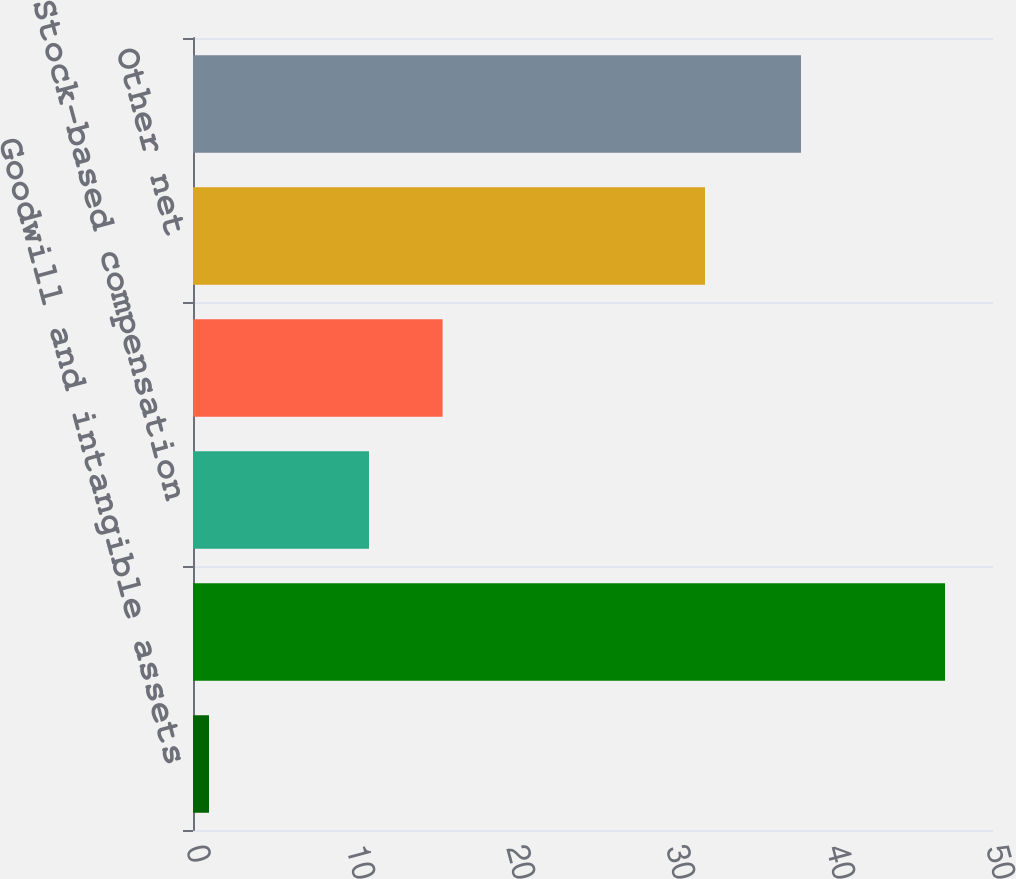<chart> <loc_0><loc_0><loc_500><loc_500><bar_chart><fcel>Goodwill and intangible assets<fcel>Pension and other retiree<fcel>Stock-based compensation<fcel>Tax loss and tax credit<fcel>Other net<fcel>Total deferred tax provision<nl><fcel>1<fcel>47<fcel>11<fcel>15.6<fcel>32<fcel>38<nl></chart> 